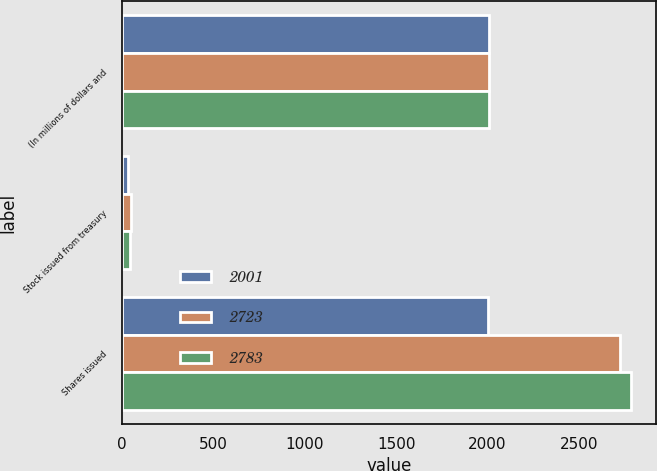Convert chart. <chart><loc_0><loc_0><loc_500><loc_500><stacked_bar_chart><ecel><fcel>(In millions of dollars and<fcel>Stock issued from treasury<fcel>Shares issued<nl><fcel>2001<fcel>2008<fcel>32<fcel>2001<nl><fcel>2723<fcel>2007<fcel>47<fcel>2723<nl><fcel>2783<fcel>2006<fcel>42<fcel>2783<nl></chart> 